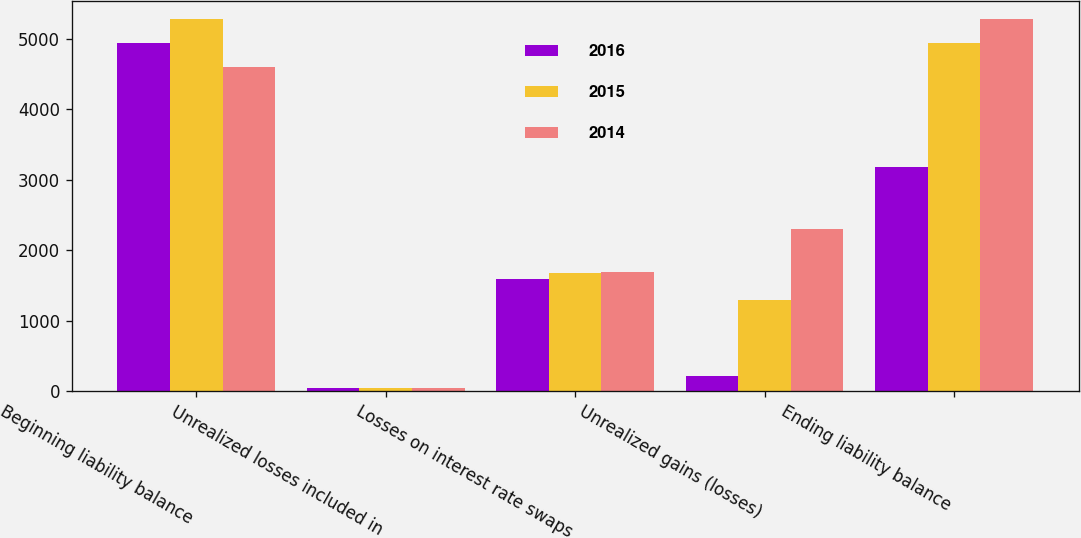Convert chart to OTSL. <chart><loc_0><loc_0><loc_500><loc_500><stacked_bar_chart><ecel><fcel>Beginning liability balance<fcel>Unrealized losses included in<fcel>Losses on interest rate swaps<fcel>Unrealized gains (losses)<fcel>Ending liability balance<nl><fcel>2016<fcel>4938<fcel>44<fcel>1586<fcel>221<fcel>3175<nl><fcel>2015<fcel>5273<fcel>44<fcel>1678<fcel>1299<fcel>4938<nl><fcel>2014<fcel>4604<fcel>48<fcel>1685<fcel>2306<fcel>5273<nl></chart> 